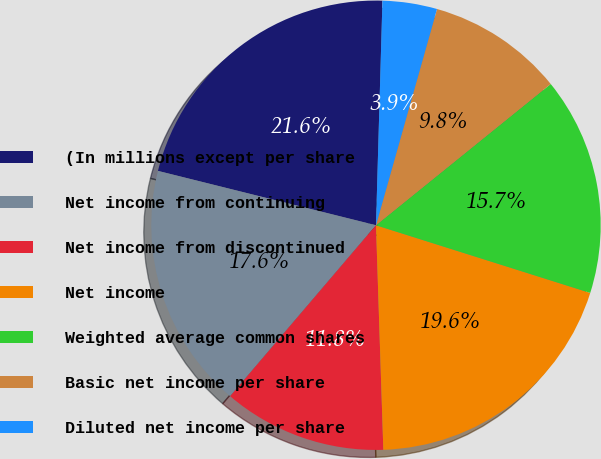Convert chart. <chart><loc_0><loc_0><loc_500><loc_500><pie_chart><fcel>(In millions except per share<fcel>Net income from continuing<fcel>Net income from discontinued<fcel>Net income<fcel>Weighted average common shares<fcel>Basic net income per share<fcel>Diluted net income per share<nl><fcel>21.57%<fcel>17.65%<fcel>11.76%<fcel>19.61%<fcel>15.69%<fcel>9.8%<fcel>3.92%<nl></chart> 